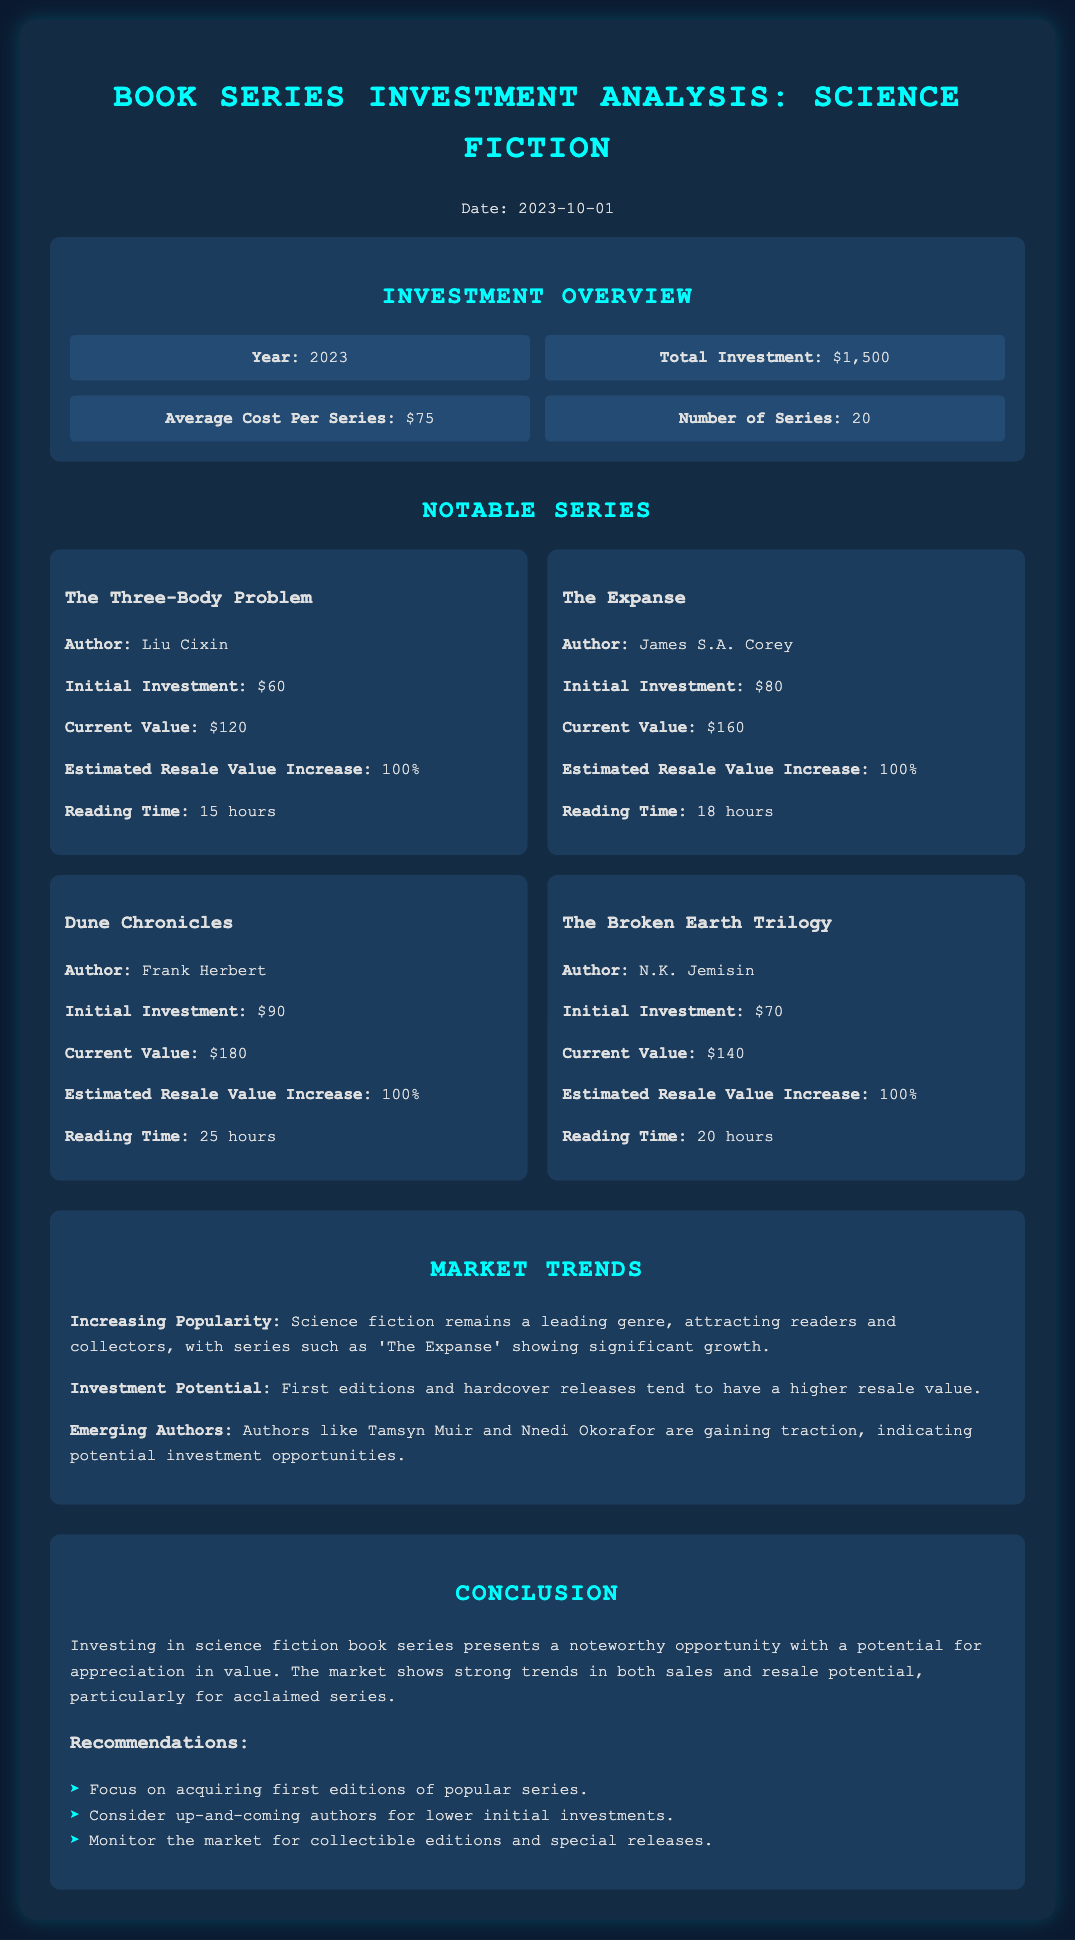What is the total investment? The total investment is clearly indicated in the overview section of the document.
Answer: $1,500 How many book series were invested in? The number of series is stated in the overview section of the document.
Answer: 20 Who is the author of "The Expanse"? The author's name is provided within the description of the series in the document.
Answer: James S.A. Corey What is the reading time for "Dune Chronicles"? The reading time is given in the card for that series in the document.
Answer: 25 hours What is the estimated resale value increase for notable series? The potential increase in resale value is mentioned in the cards for each notable series.
Answer: 100% Which series had the highest current value? The current values of all notable series can be compared to find the highest.
Answer: Dune Chronicles What is the average cost per series? The average cost is stated in the investment overview section.
Answer: $75 What investment focus is recommended? The document provides recommendations for investment focus in the conclusion section.
Answer: First editions of popular series Who is an emerging author mentioned in the trends? The trends section highlights emerging authors worth noting for potential investment.
Answer: Tamsyn Muir 